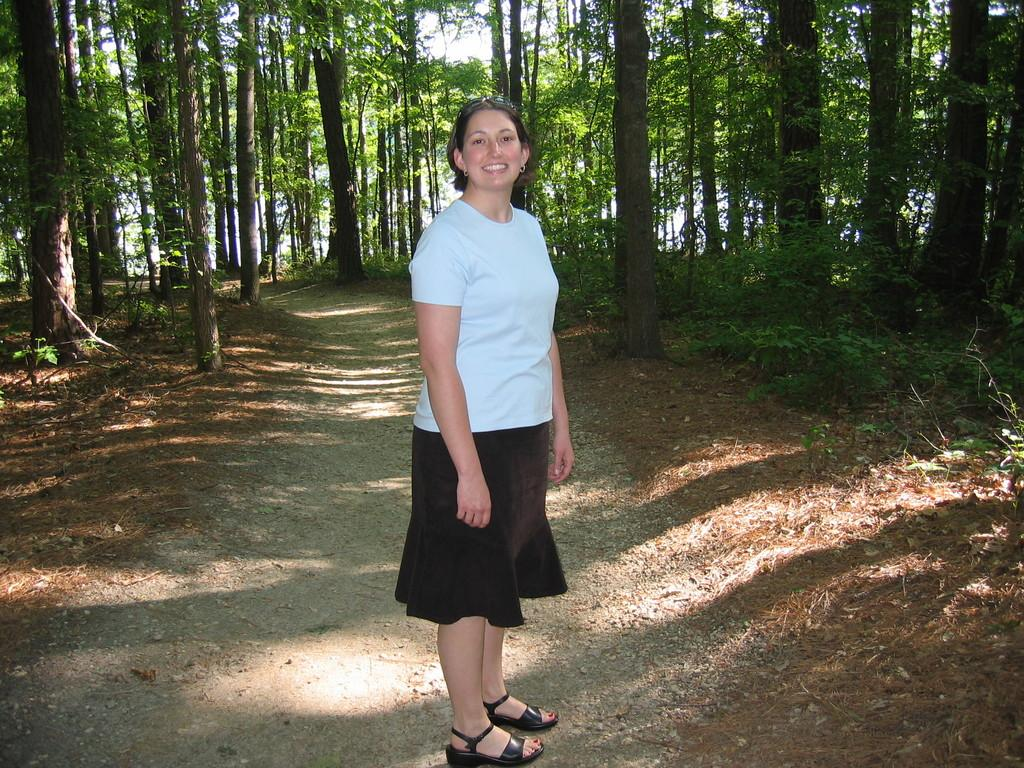Who is present in the image? There is a woman in the image. What is the woman doing in the image? The woman is smiling in the image. What is the woman wearing in the image? The woman is wearing a white and black dress in the image. What can be seen in the background of the image? There are trees visible in the image. What type of memory is the woman trying to recall in the image? There is no indication in the image that the woman is trying to recall any memory. 